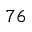<formula> <loc_0><loc_0><loc_500><loc_500>^ { 7 6 }</formula> 